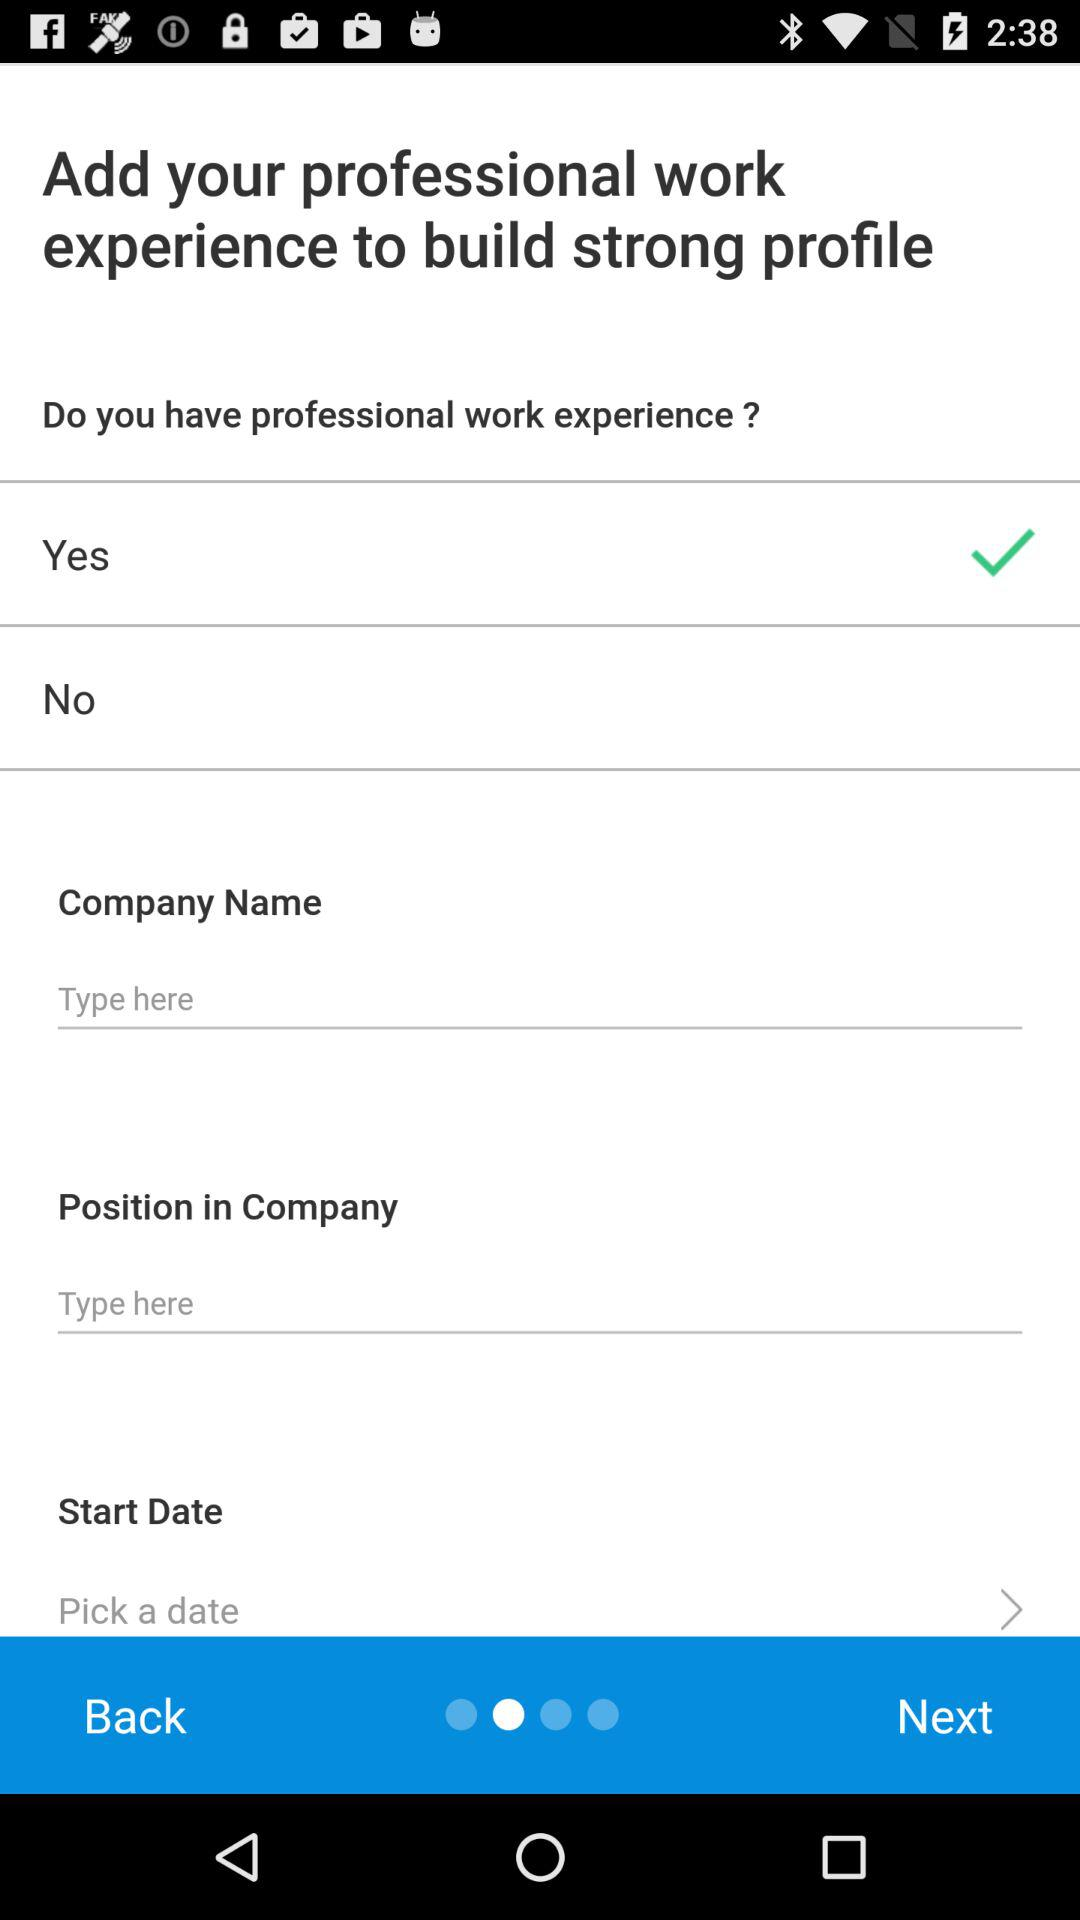How many items are there in the Company Name text input?
Answer the question using a single word or phrase. 1 